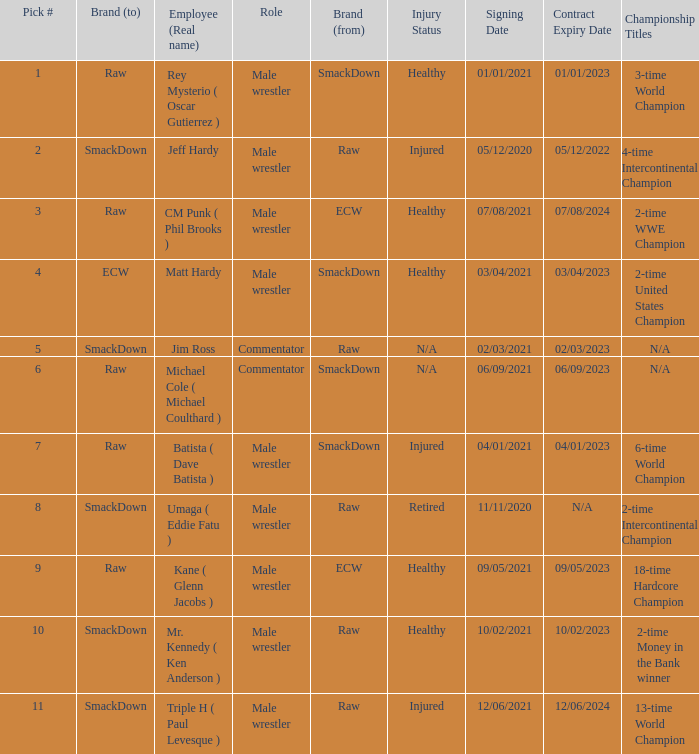Pick # 3 works for which brand? ECW. 